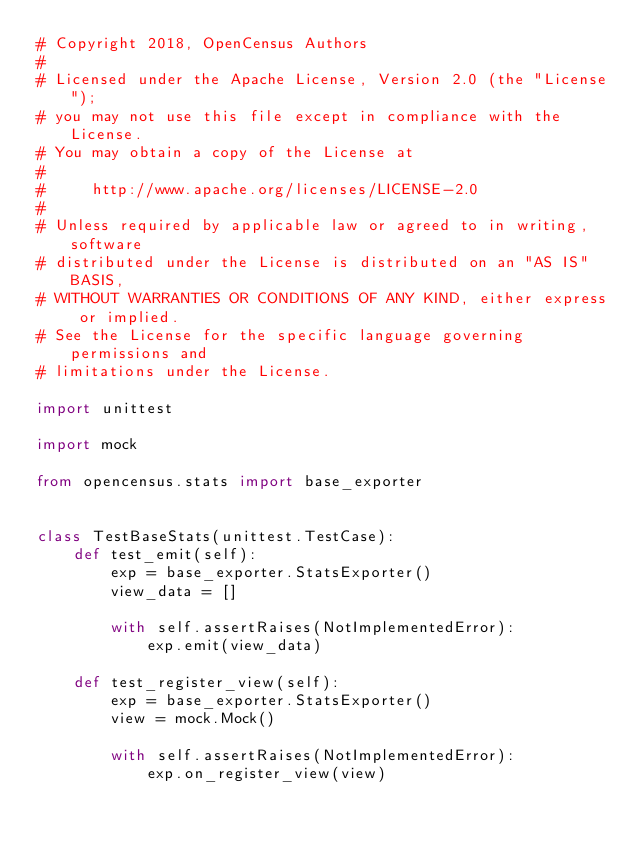Convert code to text. <code><loc_0><loc_0><loc_500><loc_500><_Python_># Copyright 2018, OpenCensus Authors
#
# Licensed under the Apache License, Version 2.0 (the "License");
# you may not use this file except in compliance with the License.
# You may obtain a copy of the License at
#
#     http://www.apache.org/licenses/LICENSE-2.0
#
# Unless required by applicable law or agreed to in writing, software
# distributed under the License is distributed on an "AS IS" BASIS,
# WITHOUT WARRANTIES OR CONDITIONS OF ANY KIND, either express or implied.
# See the License for the specific language governing permissions and
# limitations under the License.

import unittest

import mock

from opencensus.stats import base_exporter


class TestBaseStats(unittest.TestCase):
    def test_emit(self):
        exp = base_exporter.StatsExporter()
        view_data = []

        with self.assertRaises(NotImplementedError):
            exp.emit(view_data)

    def test_register_view(self):
        exp = base_exporter.StatsExporter()
        view = mock.Mock()

        with self.assertRaises(NotImplementedError):
            exp.on_register_view(view)
</code> 